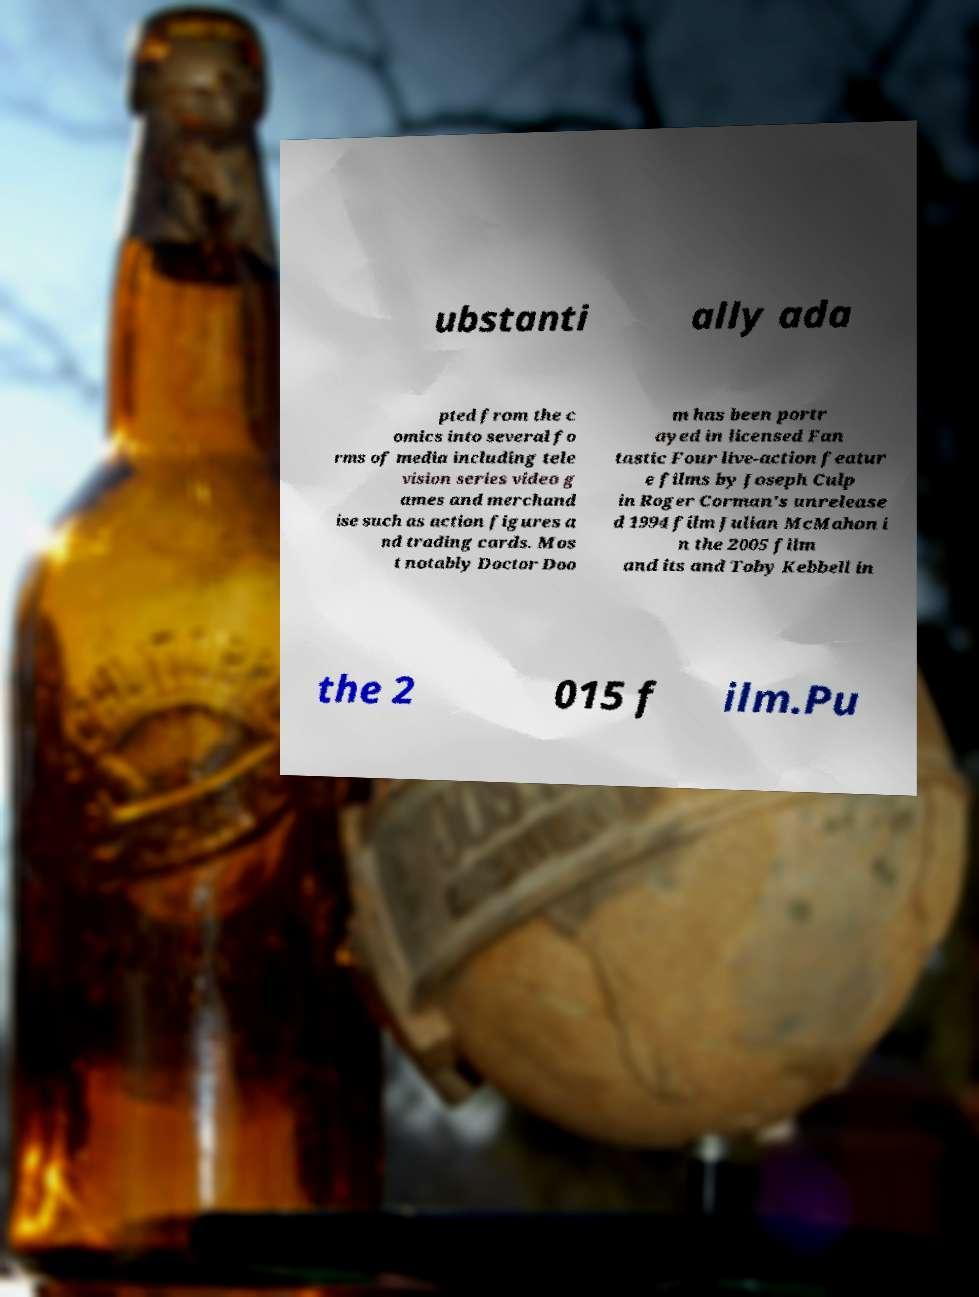Can you read and provide the text displayed in the image?This photo seems to have some interesting text. Can you extract and type it out for me? ubstanti ally ada pted from the c omics into several fo rms of media including tele vision series video g ames and merchand ise such as action figures a nd trading cards. Mos t notably Doctor Doo m has been portr ayed in licensed Fan tastic Four live-action featur e films by Joseph Culp in Roger Corman's unrelease d 1994 film Julian McMahon i n the 2005 film and its and Toby Kebbell in the 2 015 f ilm.Pu 